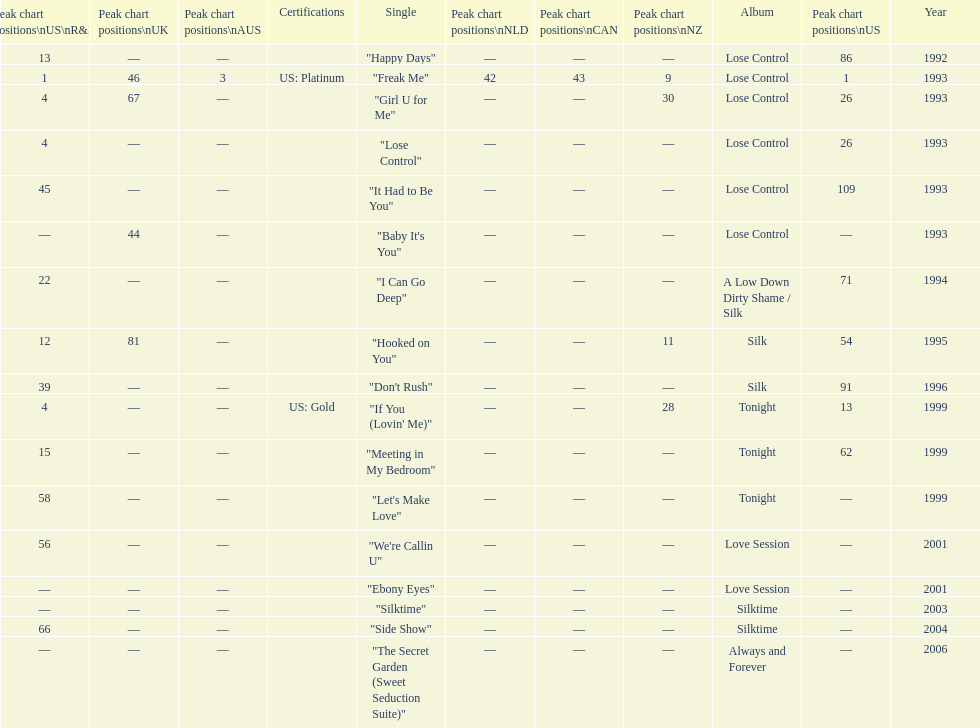Which phrase ranked higher on the us and us r&b charts: "i can go deep" or "don't rush"? "I Can Go Deep". 